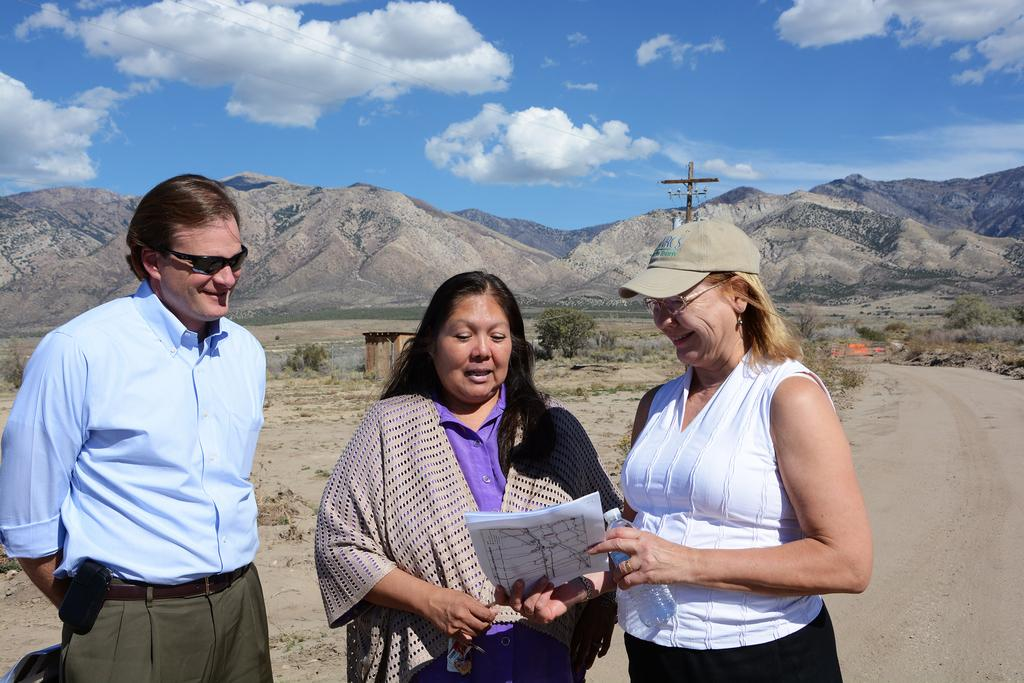What are the persons in the image doing? The persons in the image are standing on the road and holding a paper. What can be seen in the background of the image? In the background of the image, there is a shed, a pole, trees, grass, hills, and the sky. What is the condition of the sky in the image? The sky is visible in the background of the image, and there are clouds present. What type of waste can be seen being recycled by the persons in the image? There is no waste present in the image, and the persons are holding a paper, not recycling any waste. What are the persons learning from the paper they are holding in the image? The image does not provide any information about what the persons might be learning from the paper they are holding. 